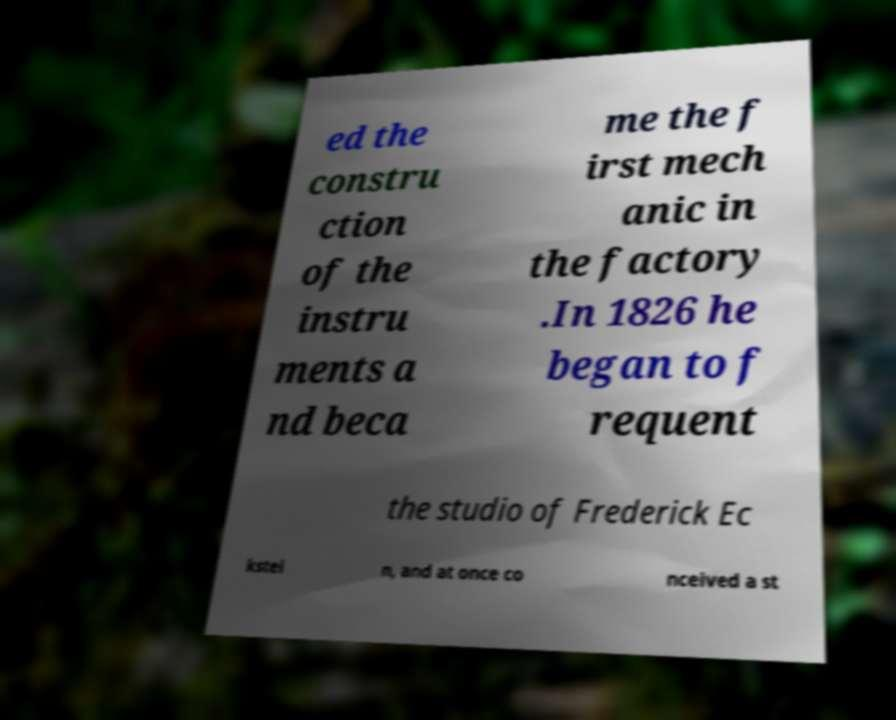I need the written content from this picture converted into text. Can you do that? ed the constru ction of the instru ments a nd beca me the f irst mech anic in the factory .In 1826 he began to f requent the studio of Frederick Ec kstei n, and at once co nceived a st 